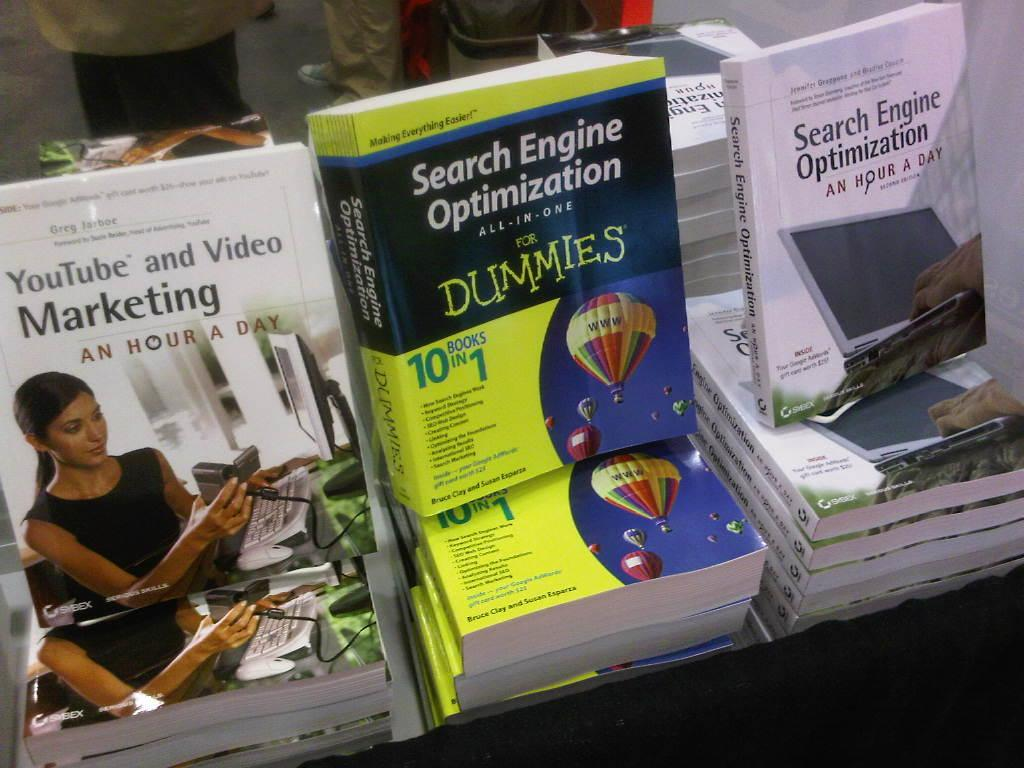<image>
Create a compact narrative representing the image presented. Instructional books for marketing and search engine optimization are displayed. 